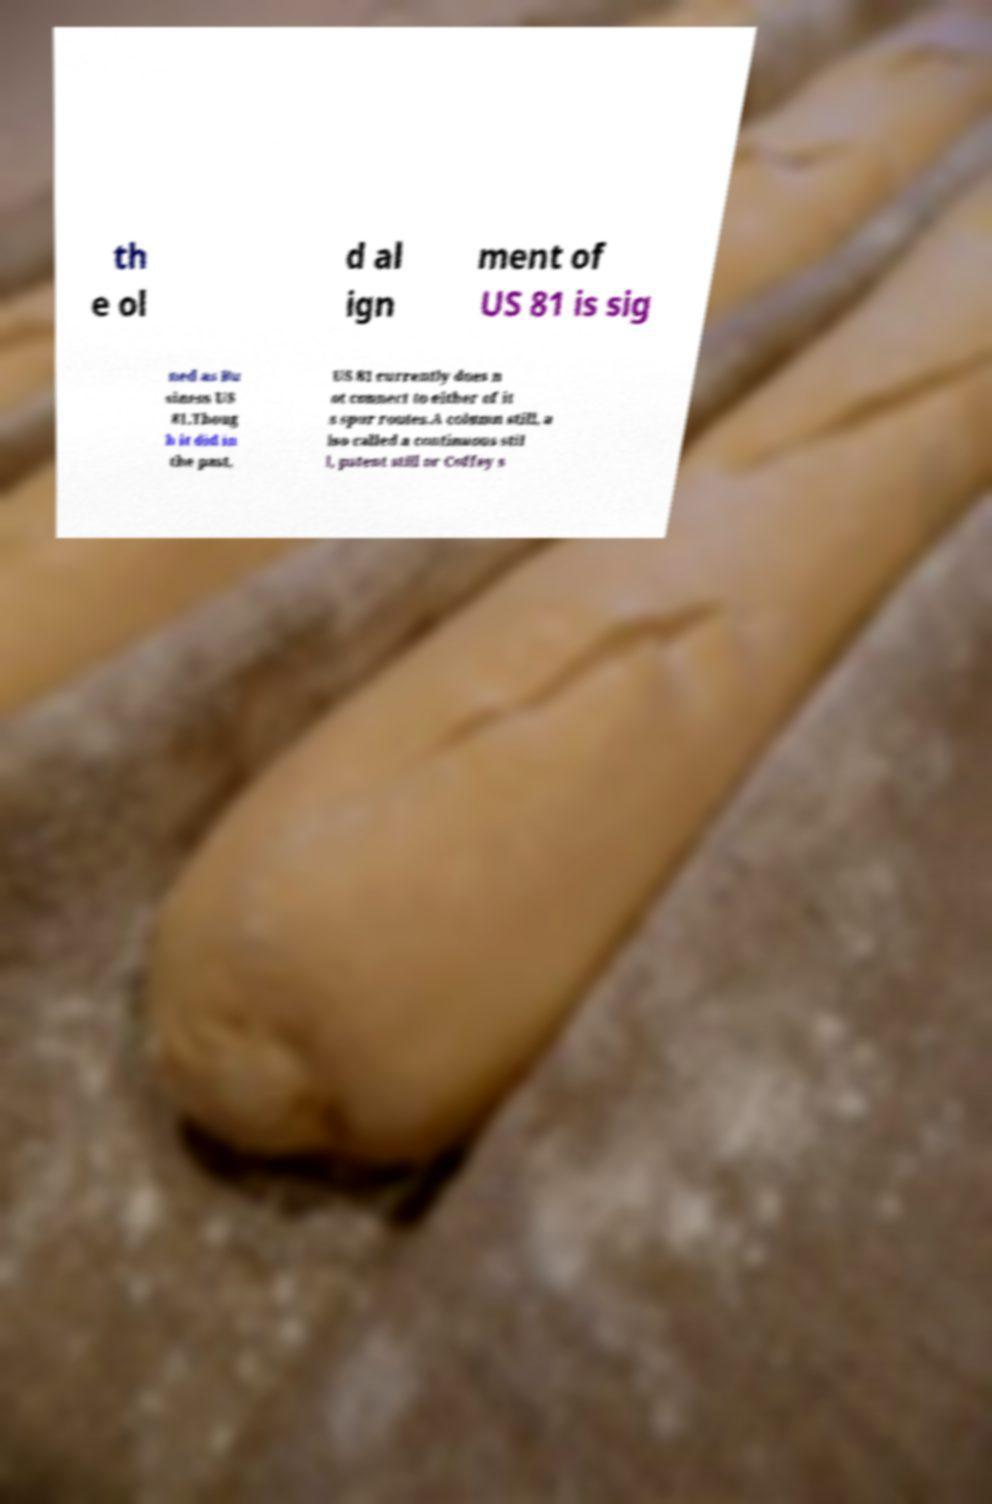Can you read and provide the text displayed in the image?This photo seems to have some interesting text. Can you extract and type it out for me? th e ol d al ign ment of US 81 is sig ned as Bu siness US 81.Thoug h it did in the past, US 81 currently does n ot connect to either of it s spur routes.A column still, a lso called a continuous stil l, patent still or Coffey s 